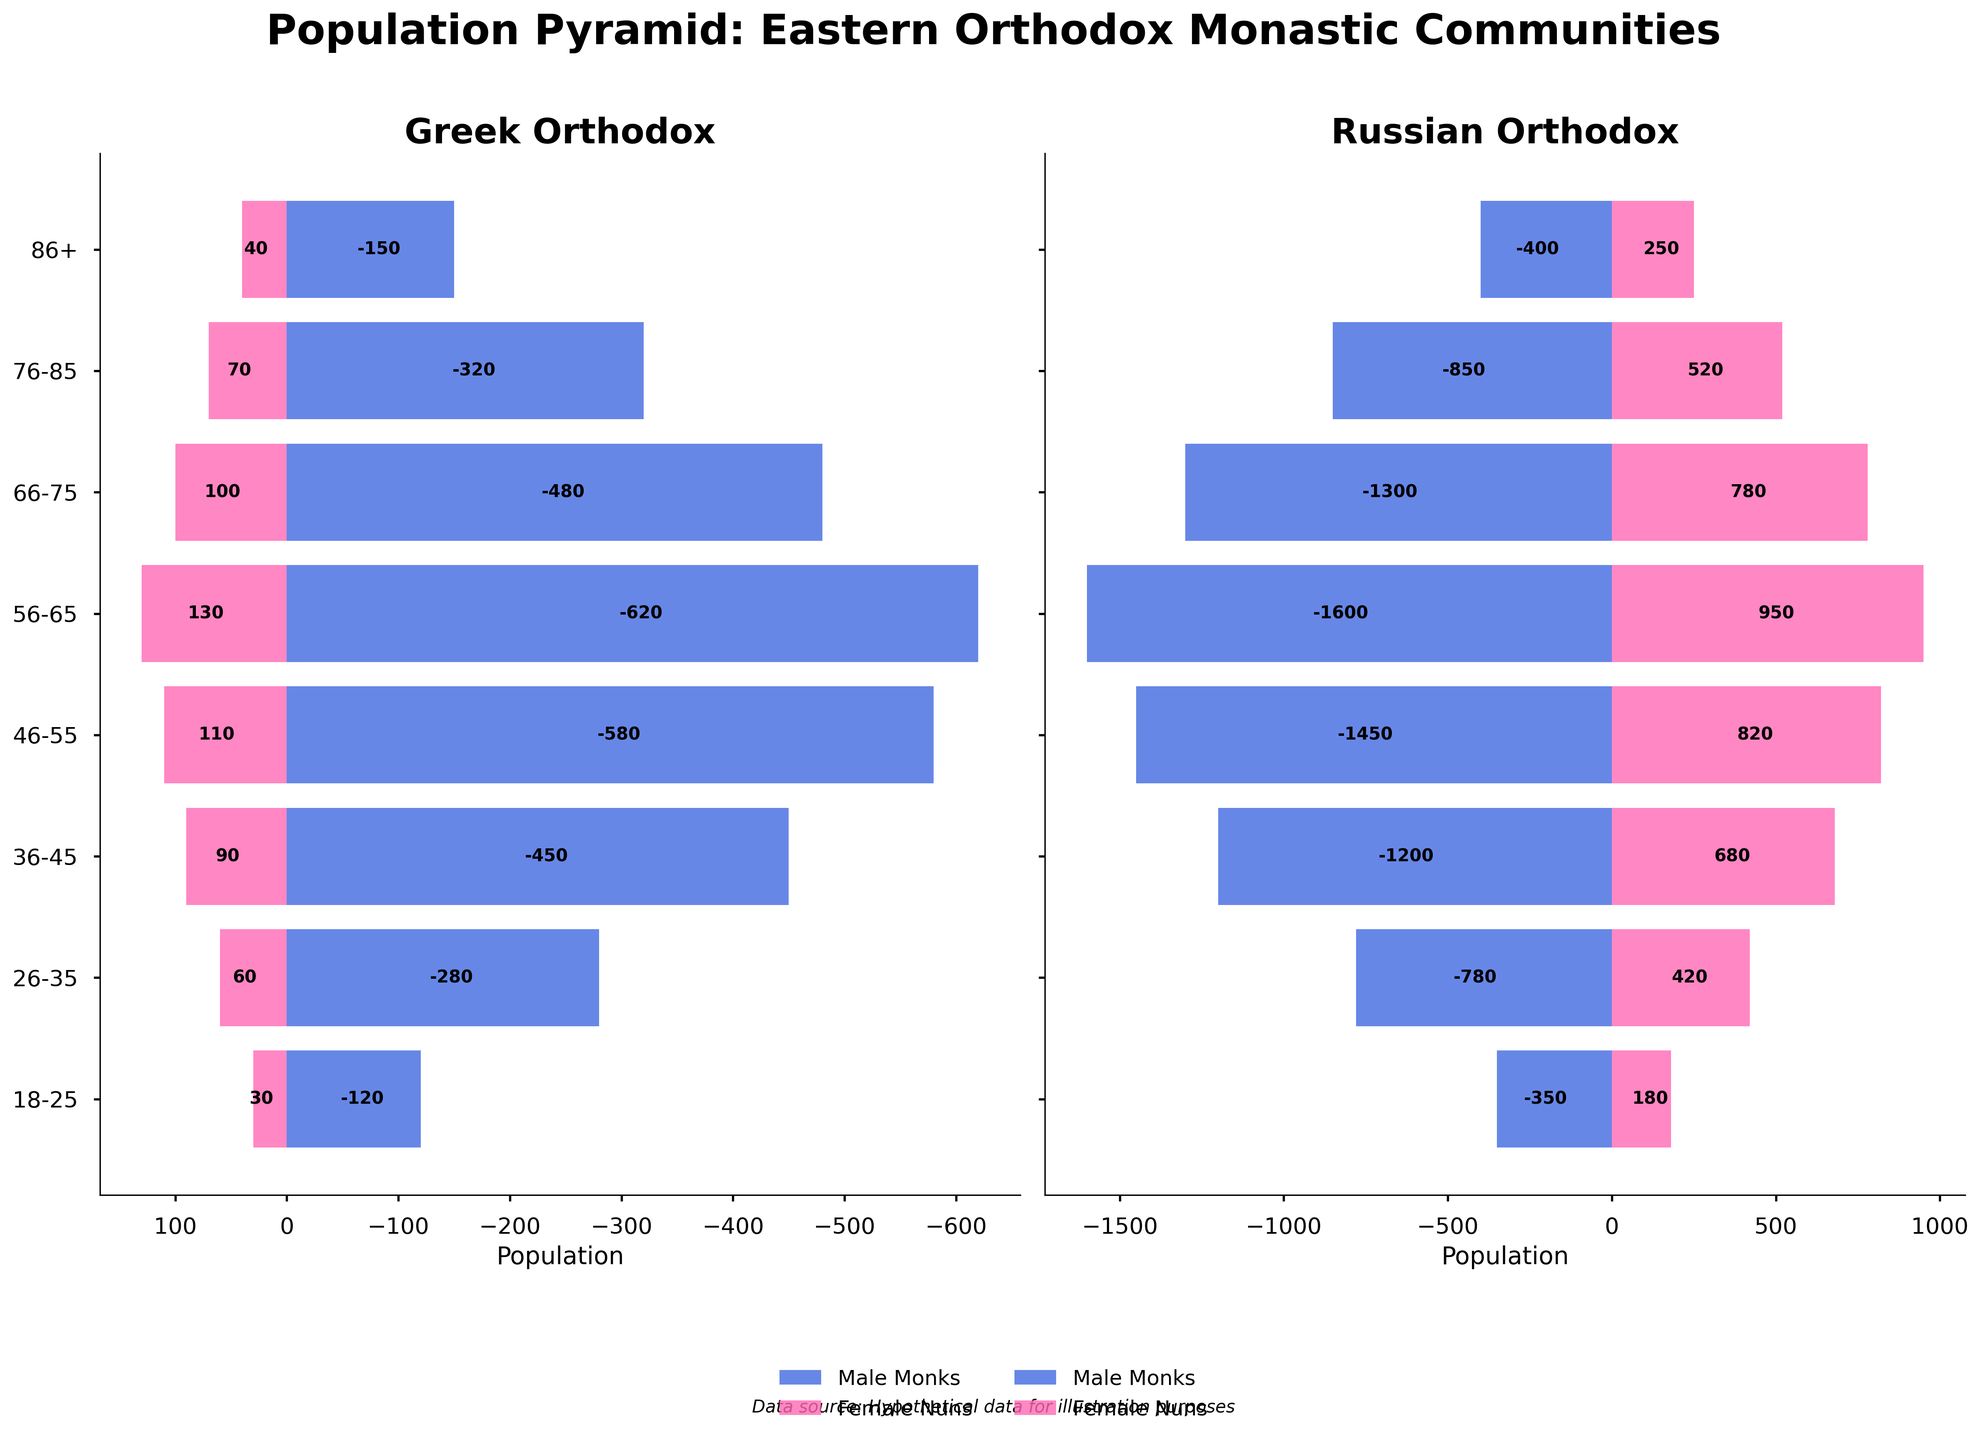What's the title of the figure? The title is displayed at the top center of the figure. It reads, "Population Pyramid: Eastern Orthodox Monastic Communities".
Answer: Population Pyramid: Eastern Orthodox Monastic Communities What are the two populations being compared in this figure? The figure differentiates and compares Greek Orthodox and Russian Orthodox monastic communities, with separate pyramids for each population.
Answer: Greek Orthodox and Russian Orthodox How many age groups are represented in the population pyramid? The age groups are listed on the y-axis, and there are eight age groups: 18-25, 26-35, 36-45, 46-55, 56-65, 66-75, 76-85, and 86+.
Answer: Eight In which age group do the Greek Male Monks have the highest population? Analyze the length of the bars for Greek Male Monks in each age group. The longest bar appears in the 56-65 age group.
Answer: 56-65 Compare the population of Russian Male Monks and Female Nuns in the 46-55 age group. Which is higher? Assess the bars representing Russian Male Monks and Female Nuns in the 46-55 age group. The bar for Russian Male Monks is longer, indicating a higher population.
Answer: Russian Male Monks What is the combined population of Greek Female Nuns and Russian Female Nuns in the 36-45 age group? The population for Greek Female Nuns is 90, and for Russian Female Nuns, it is 680. Adding them together: 90 + 680 = 770.
Answer: 770 Which community has more members aged 76-85, Greek or Russian? Compare the total lengths of bars (absolute values) for Greek and Russian communities in the 76-85 age group. The total for the Greek community is (320+70)=390 and for the Russian community is (850+520)=1370.
Answer: Russian In the 18-25 age group, how does the number of Russian Male Monks compare to Greek Male Monks? Compare the lengths of the bars for Russian Male Monks (350) and Greek Male Monks (120). The bar for Russian Male Monks is longer.
Answer: Russian Male Monks have more What is the total population of Greek Male Monks across all age groups? Sum the Greek Male Monks: 120 + 280 + 450 + 580 + 620 + 480 + 320 + 150. The total is 3000.
Answer: 3000 Which age group among Russian Female Nuns has the lowest population? The shortest bar for Russian Female Nuns is in the 86+ age group (250).
Answer: 86+ 